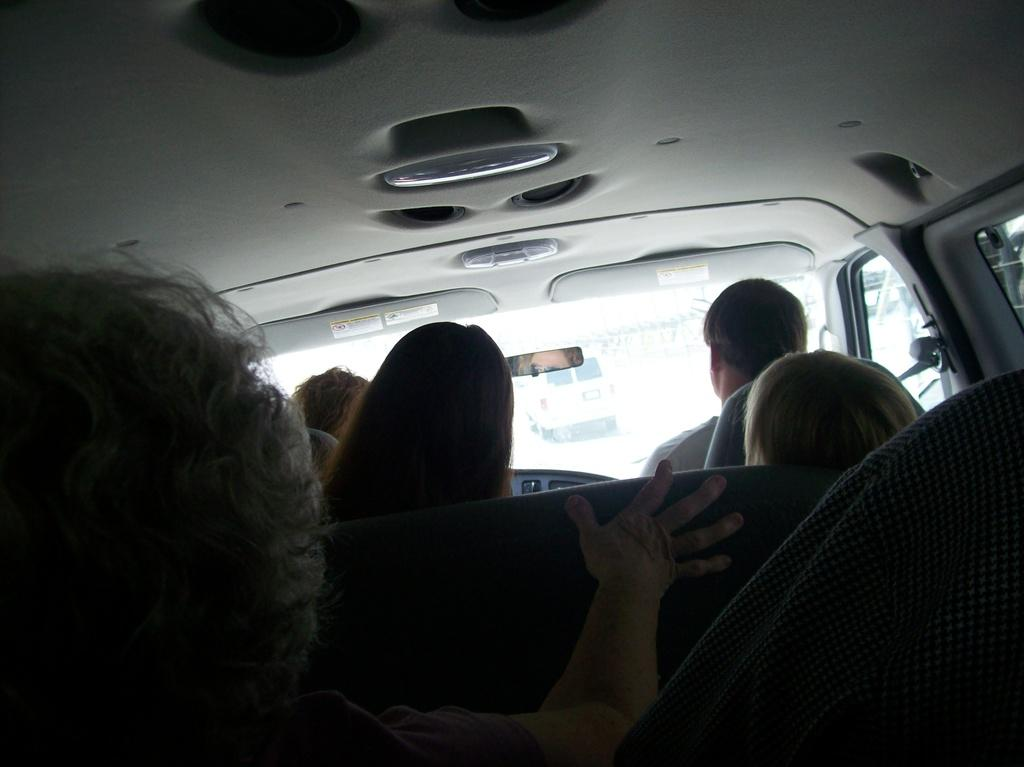What are the people in the image doing? There is a group of people sitting on a car in the image. Can you describe the background of the image? There is another car visible in the background, and there is a road in the background. What type of cushion is the grandfather using to sit on the car? There is no grandfather or cushion present in the image. 